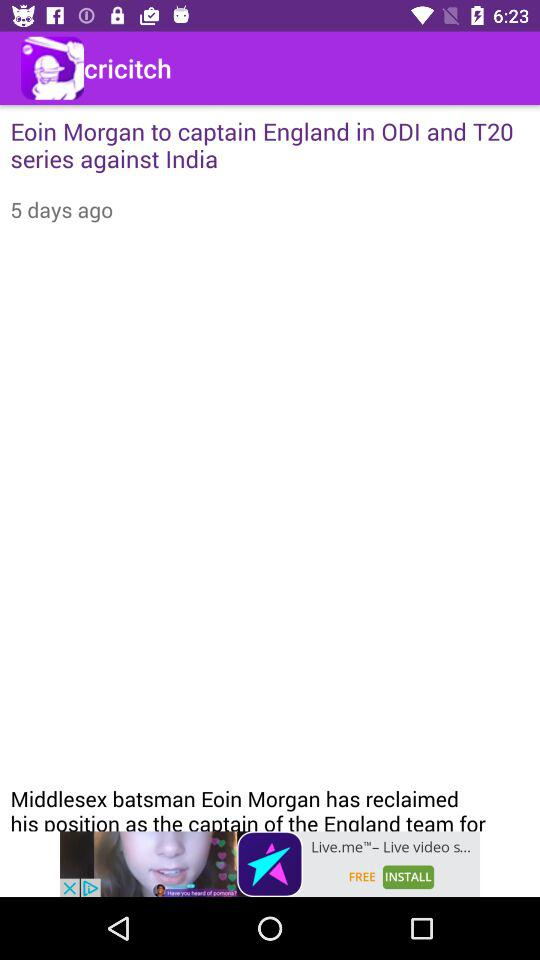How many days ago was the news posted? The news was posted 5 days ago. 